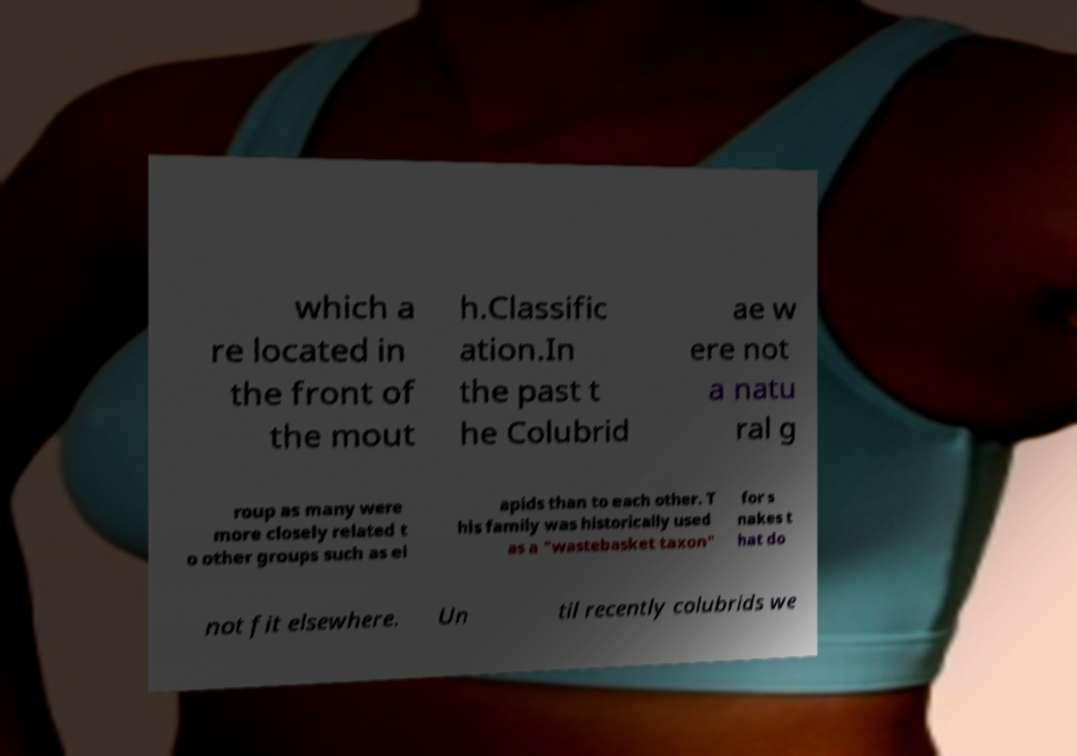Could you extract and type out the text from this image? which a re located in the front of the mout h.Classific ation.In the past t he Colubrid ae w ere not a natu ral g roup as many were more closely related t o other groups such as el apids than to each other. T his family was historically used as a "wastebasket taxon" for s nakes t hat do not fit elsewhere. Un til recently colubrids we 